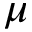Convert formula to latex. <formula><loc_0><loc_0><loc_500><loc_500>\mu</formula> 